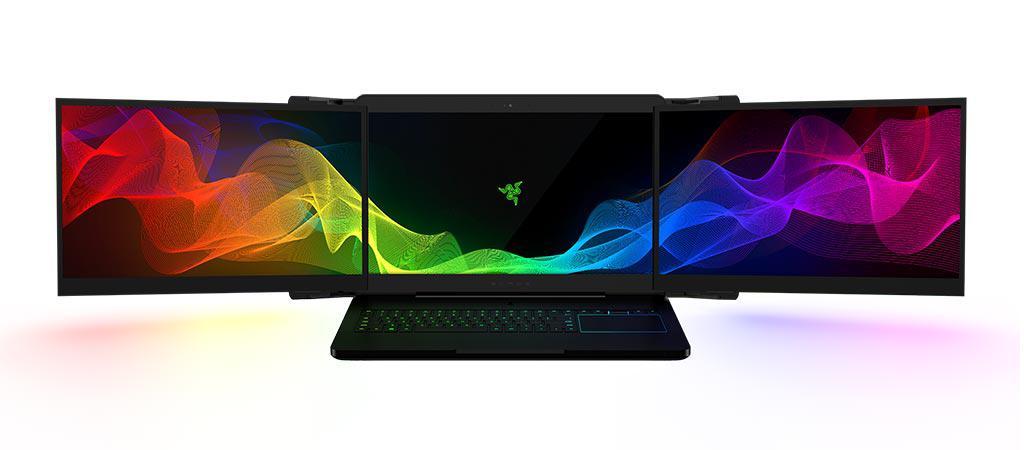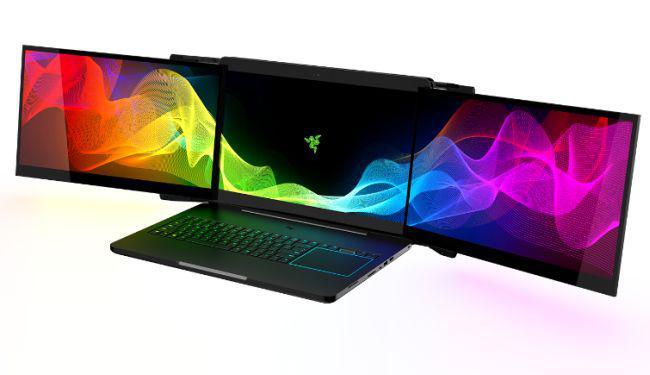The first image is the image on the left, the second image is the image on the right. Analyze the images presented: Is the assertion "there is a latop on a desk with 2 extra monitors mounted to the original screen" valid? Answer yes or no. No. The first image is the image on the left, the second image is the image on the right. Evaluate the accuracy of this statement regarding the images: "At least one triple-screen laptop is displayed head-on instead of at an angle, and the three screens of at least one device create a unified image of flowing ribbons of color.". Is it true? Answer yes or no. Yes. 